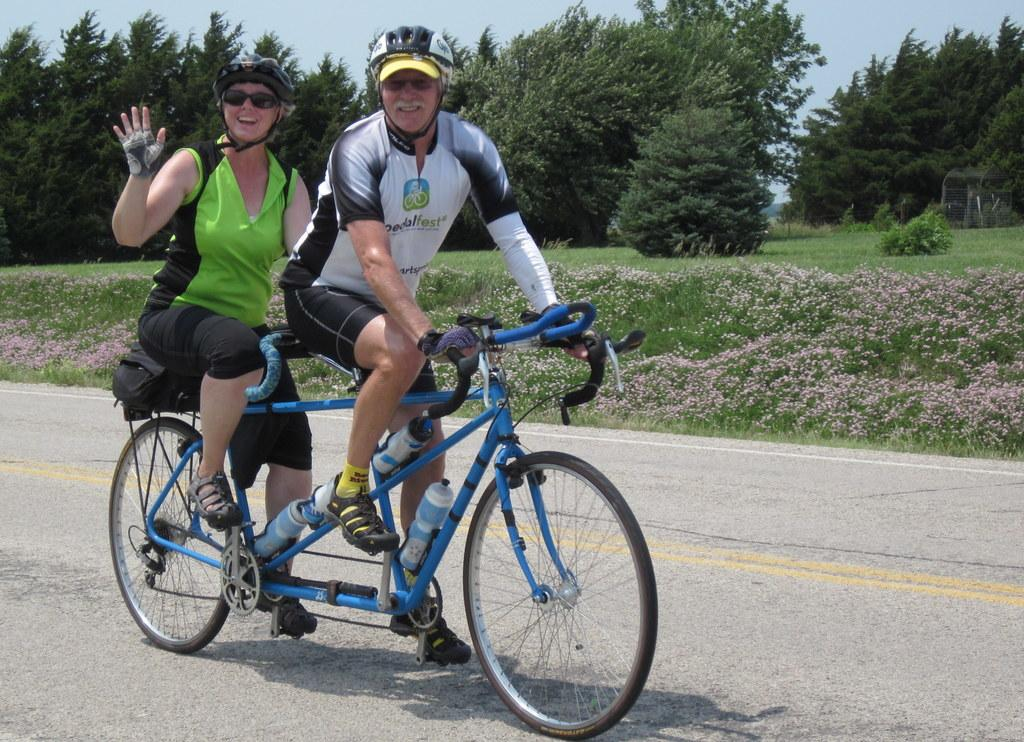How many people are in the image? There are two persons in the image. What are the two persons doing in the image? The two persons are riding a bicycle. What safety precautions are the persons taking in the image? The persons are wearing helmets. What can be seen in the background of the image? There are trees, the ground, flowers, and a clear sky visible in the background of the image. What type of silk fabric is draped over the kittens in the image? There are no kittens or silk fabric present in the image. What tax policy is being discussed by the two persons riding the bicycle in the image? There is no discussion of tax policy in the image; the two persons are simply riding a bicycle. 